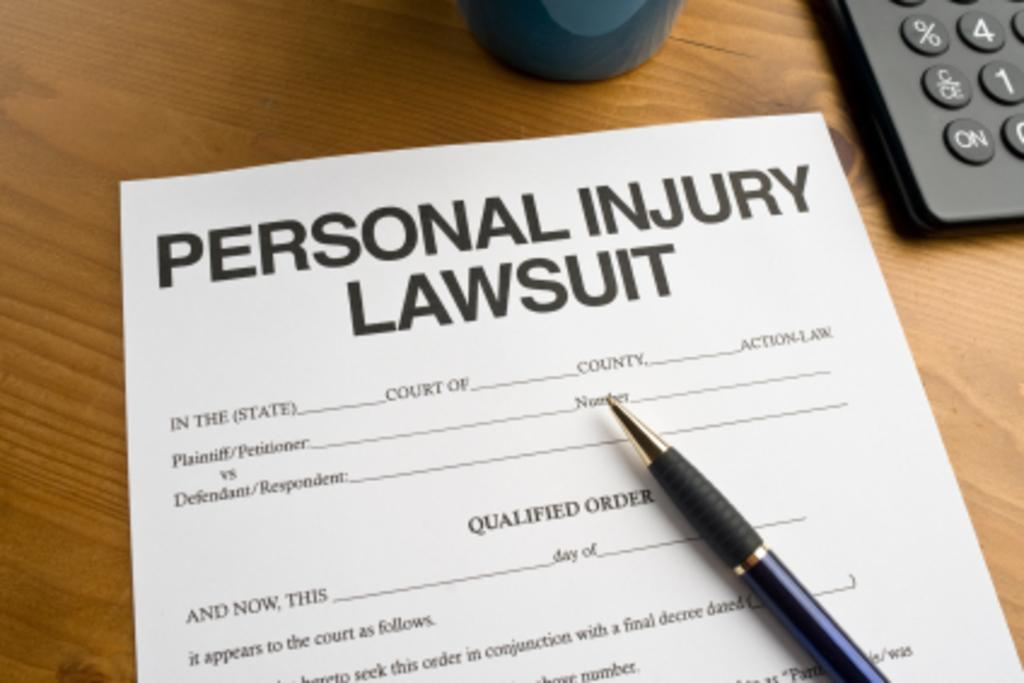<image>
Offer a succinct explanation of the picture presented. A pen sits on top of a Personal Injury Lawsuit application. 